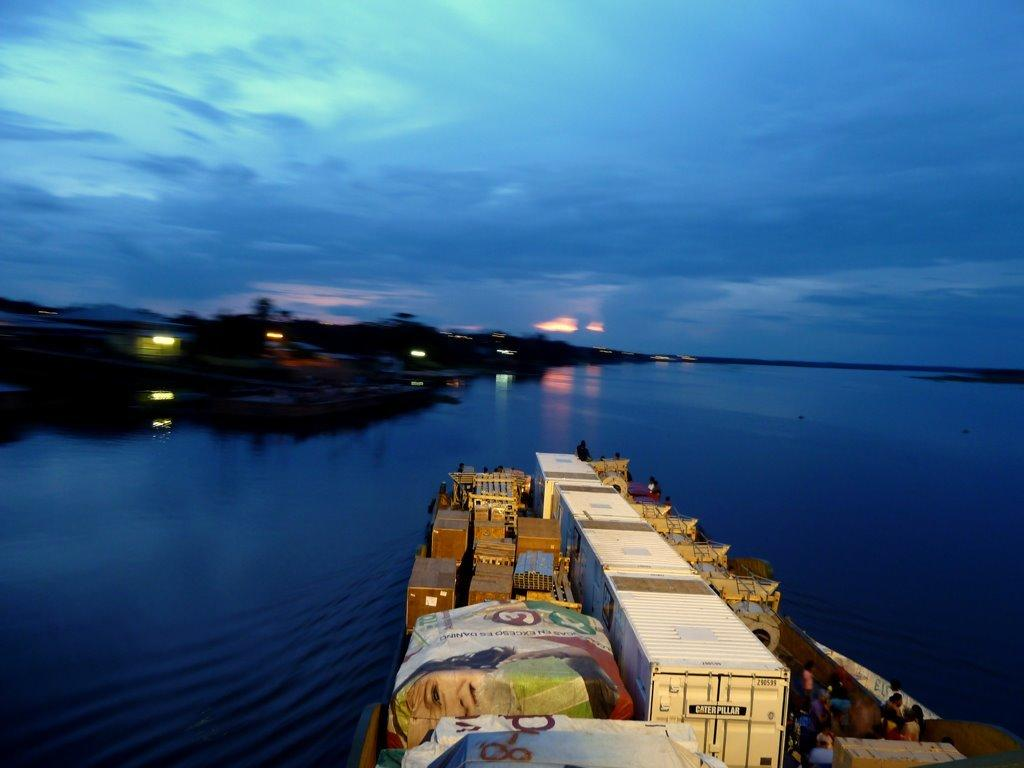What is the main subject of the image? The main subject of the image is a ship. What is inside the ship? The ship contains goods. What is the setting of the image? There is water visible in the image, suggesting that the ship is on the water. What can be seen on the left side of the image? There are lights on the left side of the image. What is the color of the sky in the image? The sky is blue in the image. What type of crime is being committed in the image? There is no crime being committed in the image; it features a ship on the water. Where is the mailbox located in the image? There is no mailbox present in the image. 